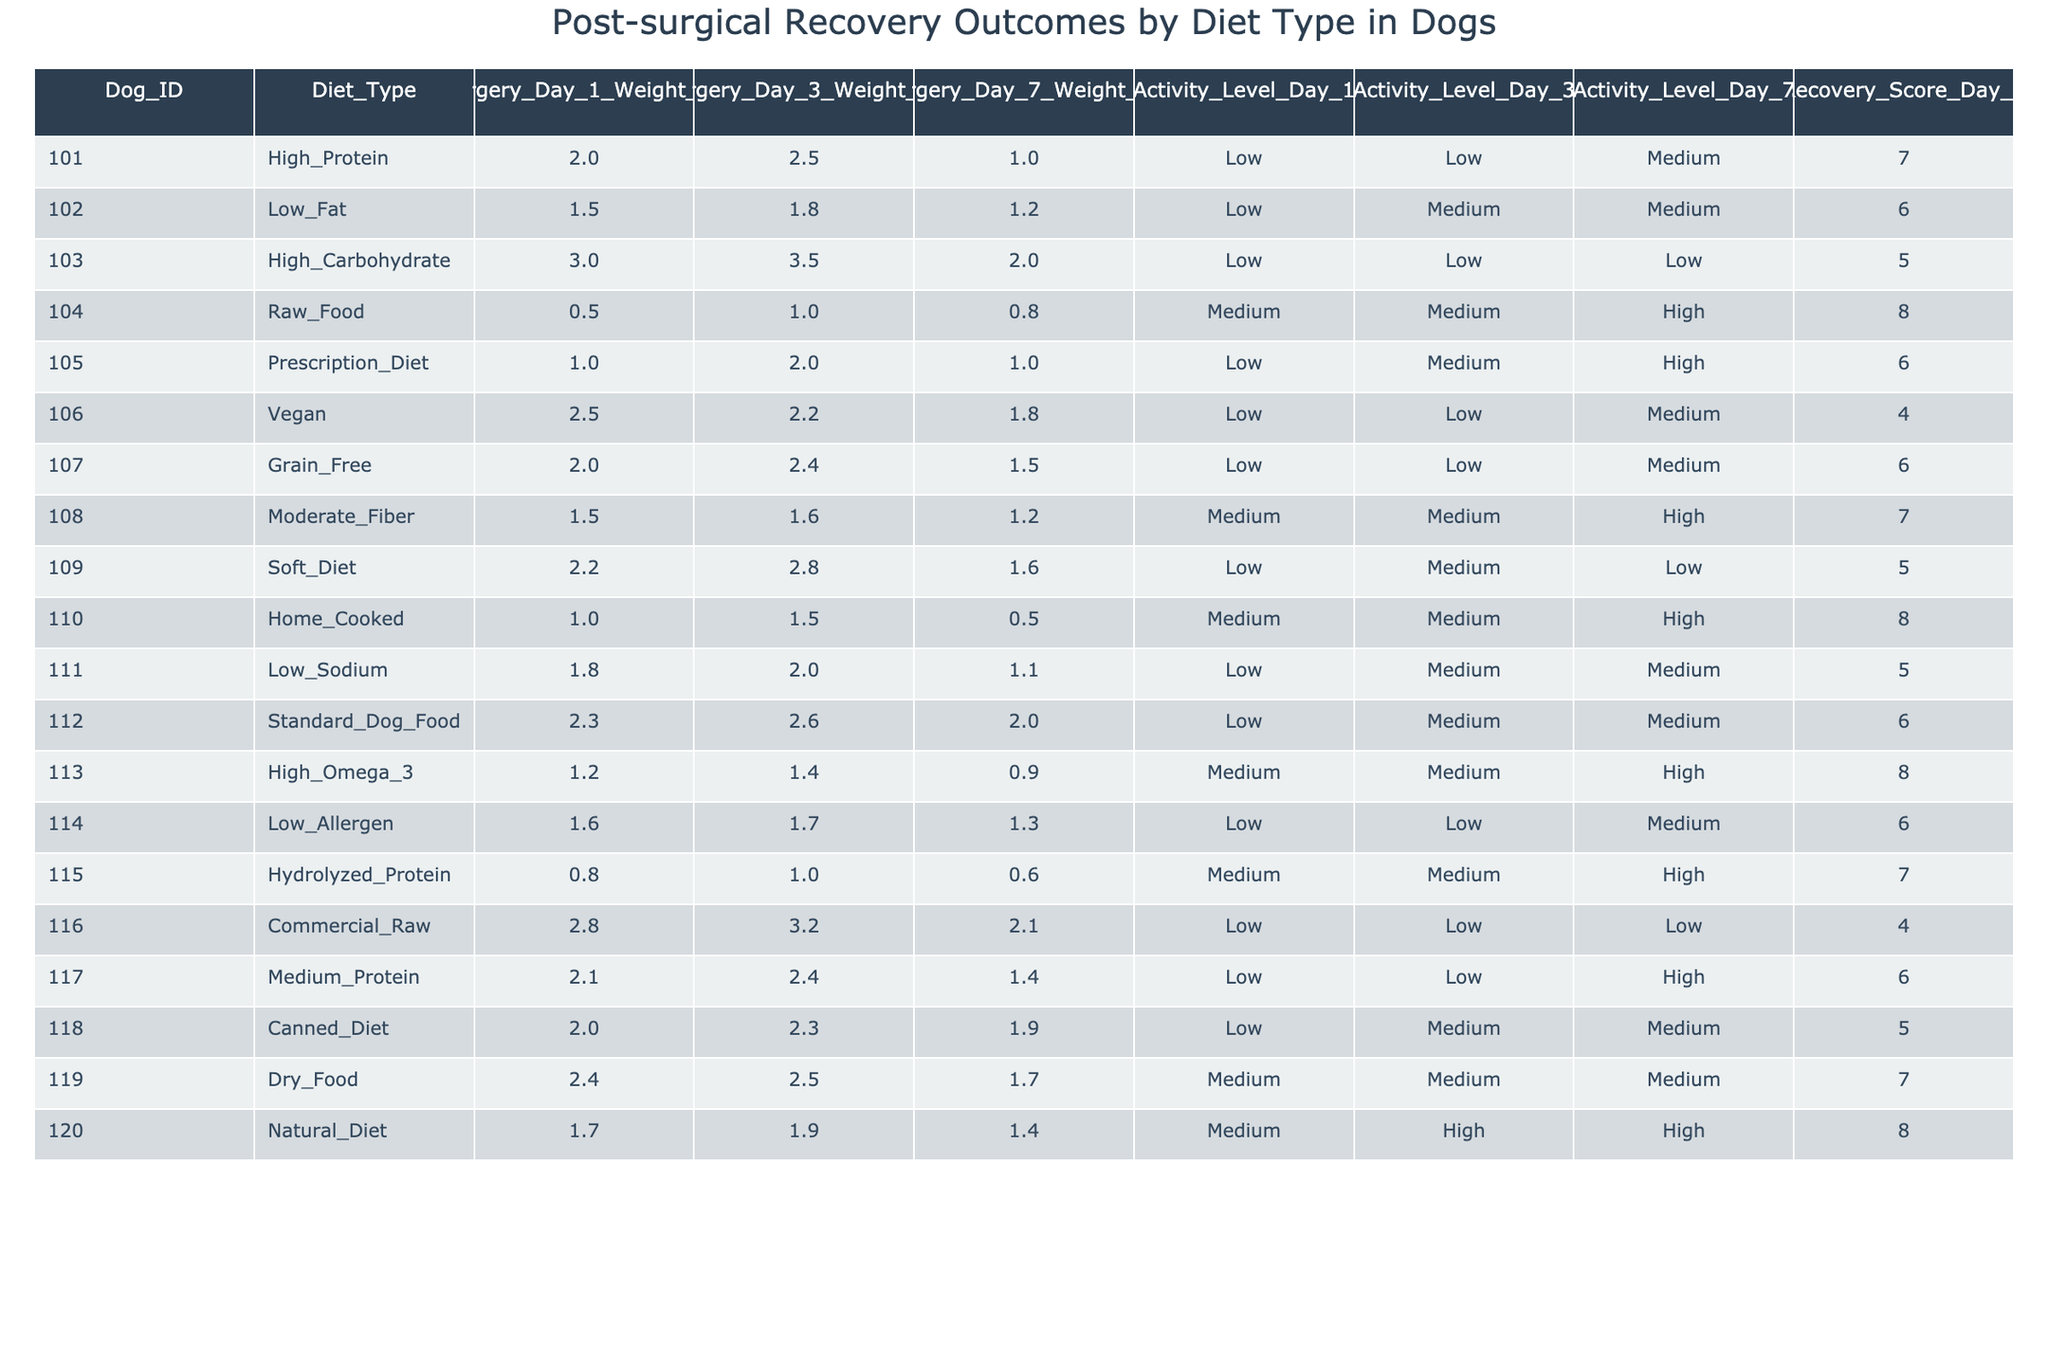What was the highest recovery score on Day 7? The highest recovery score listed in the table is 8, which corresponds to the diets of Raw Food, Home Cooked, and Natural Diet.
Answer: 8 Which diet type had the greatest weight loss on Day 1? The highest percentage of weight loss on Day 1 is 3% for the High Carbohydrate diet.
Answer: High Carbohydrate What is the average recovery score for dogs on a Vegan diet? There is only one entry for the Vegan diet with a recovery score of 4. Thus, the average is 4.
Answer: 4 Did any dogs on the Raw Food diet lose less than 1% weight by Day 1? The Raw Food diet recorded a weight loss of 0.5% on Day 1, which is less than 1%.
Answer: Yes What is the difference in weight loss percentage on Day 7 between the High Protein and Low Fat diets? The High Protein diet had 1% weight loss on Day 7, while the Low Fat diet had 1.2%, leading to a difference of 0.2%.
Answer: 0.2% Which diet types had a recovery score of 6 and what was their Day 3 weight loss? The diet types with a recovery score of 6 are Low Fat (1.8%), Prescription Diet (2%), Grain Free (2.4%), Standard Dog Food (2.6%), and Low Allergen (1.7%).
Answer: Low Fat 1.8%, Prescription Diet 2%, Grain Free 2.4%, Standard Dog Food 2.6%, Low Allergen 1.7% What was the weight loss on Day 3 for the diet that had the least weight loss on Day 1? The diet with the least weight loss on Day 1 is Raw Food with 0.5%, which had a weight loss of 1% on Day 3.
Answer: 1% How many diet types achieved a recovery score of 8? The diets that achieved a recovery score of 8 are Raw Food, Home Cooked, and Natural Diet, totaling three types.
Answer: 3 Which diet had the highest weight loss on Day 7 and what was the recovery score? The diet with the highest weight loss on Day 7 is High Carbohydrate at 2%, and its recovery score is 5.
Answer: High Carbohydrate, 5 Was there a diet type that had a consistently increasing weight loss percentage across all three days? The Raw Food diet had increasing weight loss values from Day 1 (0.5%) to Day 3 (1%) to Day 7 (0.8%).
Answer: Yes What is the average weight loss on Day 3 for diets classified as Low? The diets classified as Low are High Protein (2.5%), Low Fat (1.8%), High Carbohydrate (3.5%), Vegan (2.2%), Grain Free (2.4%), Soft Diet (2.8%), Low Sodium (2%), and Low Allergen (1.7%). The average is (2.5 + 1.8 + 3.5 + 2.2 + 2.4 + 2.8 + 2 + 1.7) / 8 = 2.7%.
Answer: 2.7% 